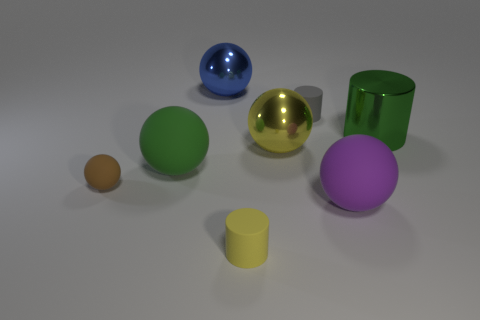Subtract all tiny brown spheres. How many spheres are left? 4 Subtract all green cylinders. Subtract all brown blocks. How many cylinders are left? 2 Add 1 tiny cyan metal spheres. How many objects exist? 9 Subtract all spheres. How many objects are left? 3 Add 5 spheres. How many spheres exist? 10 Subtract 0 cyan spheres. How many objects are left? 8 Subtract all tiny cylinders. Subtract all blue balls. How many objects are left? 5 Add 7 yellow rubber objects. How many yellow rubber objects are left? 8 